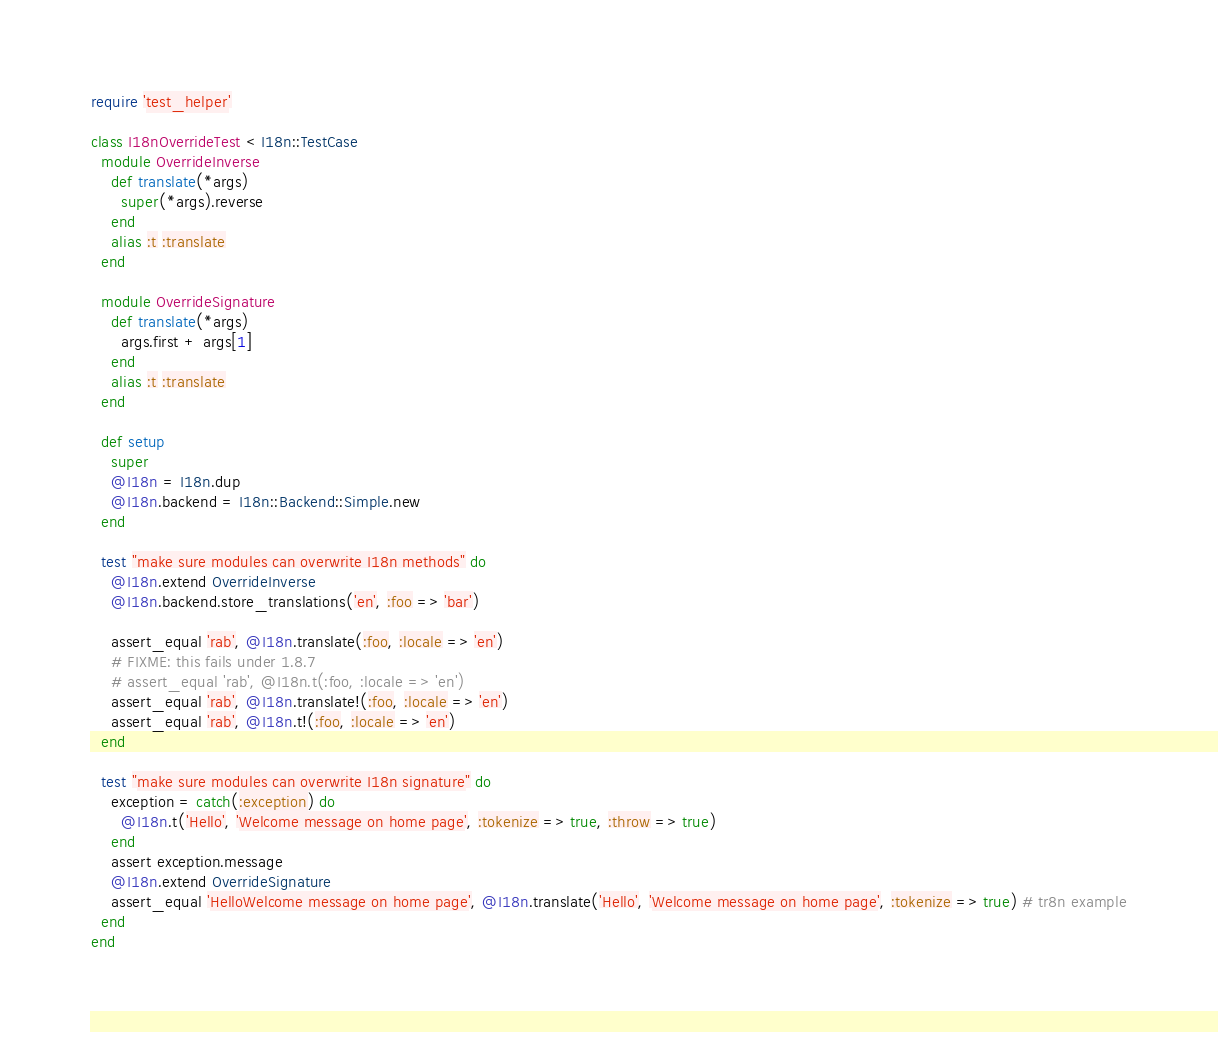<code> <loc_0><loc_0><loc_500><loc_500><_Ruby_>require 'test_helper'

class I18nOverrideTest < I18n::TestCase
  module OverrideInverse
    def translate(*args)
      super(*args).reverse
    end
    alias :t :translate
  end

  module OverrideSignature
    def translate(*args)
      args.first + args[1]
    end
    alias :t :translate
  end

  def setup
    super
    @I18n = I18n.dup
    @I18n.backend = I18n::Backend::Simple.new
  end

  test "make sure modules can overwrite I18n methods" do
    @I18n.extend OverrideInverse
    @I18n.backend.store_translations('en', :foo => 'bar')

    assert_equal 'rab', @I18n.translate(:foo, :locale => 'en')
    # FIXME: this fails under 1.8.7
    # assert_equal 'rab', @I18n.t(:foo, :locale => 'en')
    assert_equal 'rab', @I18n.translate!(:foo, :locale => 'en')
    assert_equal 'rab', @I18n.t!(:foo, :locale => 'en')
  end

  test "make sure modules can overwrite I18n signature" do
    exception = catch(:exception) do
      @I18n.t('Hello', 'Welcome message on home page', :tokenize => true, :throw => true)
    end
    assert exception.message
    @I18n.extend OverrideSignature
    assert_equal 'HelloWelcome message on home page', @I18n.translate('Hello', 'Welcome message on home page', :tokenize => true) # tr8n example
  end
end
</code> 